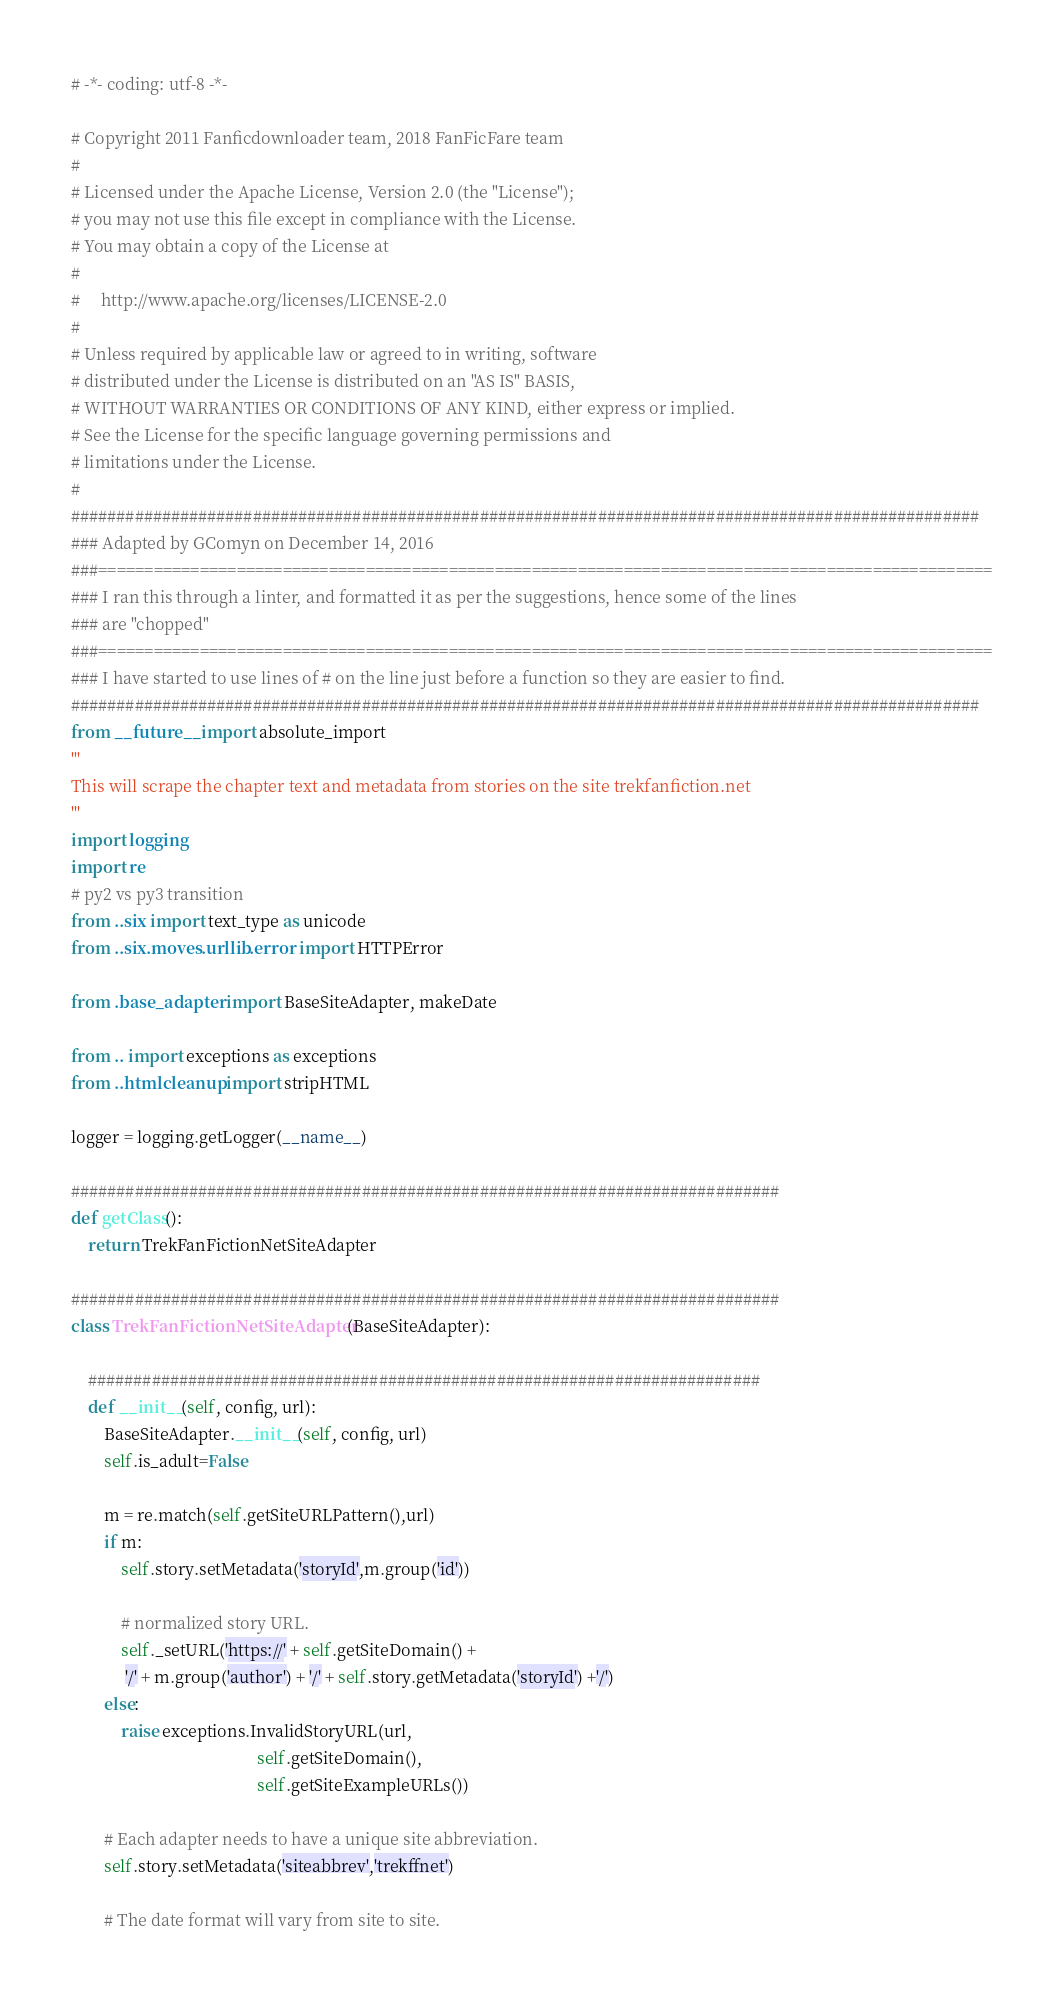<code> <loc_0><loc_0><loc_500><loc_500><_Python_># -*- coding: utf-8 -*-

# Copyright 2011 Fanficdownloader team, 2018 FanFicFare team
#
# Licensed under the Apache License, Version 2.0 (the "License");
# you may not use this file except in compliance with the License.
# You may obtain a copy of the License at
#
#     http://www.apache.org/licenses/LICENSE-2.0
#
# Unless required by applicable law or agreed to in writing, software
# distributed under the License is distributed on an "AS IS" BASIS,
# WITHOUT WARRANTIES OR CONDITIONS OF ANY KIND, either express or implied.
# See the License for the specific language governing permissions and
# limitations under the License.
#
####################################################################################################
### Adapted by GComyn on December 14, 2016
###=================================================================================================
### I ran this through a linter, and formatted it as per the suggestions, hence some of the lines
### are "chopped"
###=================================================================================================
### I have started to use lines of # on the line just before a function so they are easier to find.
####################################################################################################
from __future__ import absolute_import
'''
This will scrape the chapter text and metadata from stories on the site trekfanfiction.net
'''
import logging
import re
# py2 vs py3 transition
from ..six import text_type as unicode
from ..six.moves.urllib.error import HTTPError

from .base_adapter import BaseSiteAdapter, makeDate

from .. import exceptions as exceptions
from ..htmlcleanup import stripHTML

logger = logging.getLogger(__name__)

##############################################################################
def getClass():
    return TrekFanFictionNetSiteAdapter

##############################################################################
class TrekFanFictionNetSiteAdapter(BaseSiteAdapter):

    ##########################################################################
    def __init__(self, config, url):
        BaseSiteAdapter.__init__(self, config, url)
        self.is_adult=False

        m = re.match(self.getSiteURLPattern(),url)
        if m:
            self.story.setMetadata('storyId',m.group('id'))

            # normalized story URL.
            self._setURL('https://' + self.getSiteDomain() +
             '/' + m.group('author') + '/' + self.story.getMetadata('storyId') +'/')
        else:
            raise exceptions.InvalidStoryURL(url,
                                             self.getSiteDomain(),
                                             self.getSiteExampleURLs())

        # Each adapter needs to have a unique site abbreviation.
        self.story.setMetadata('siteabbrev','trekffnet')

        # The date format will vary from site to site.</code> 